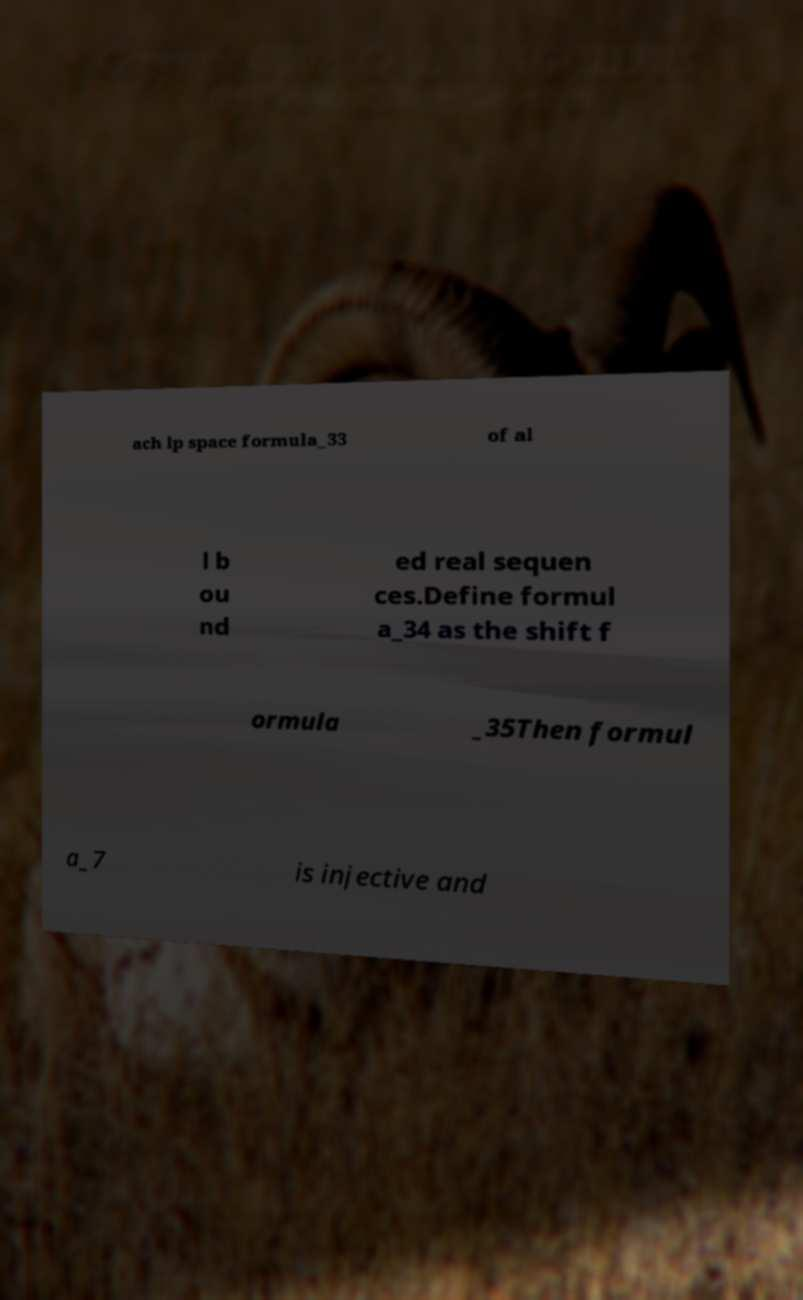There's text embedded in this image that I need extracted. Can you transcribe it verbatim? ach lp space formula_33 of al l b ou nd ed real sequen ces.Define formul a_34 as the shift f ormula _35Then formul a_7 is injective and 